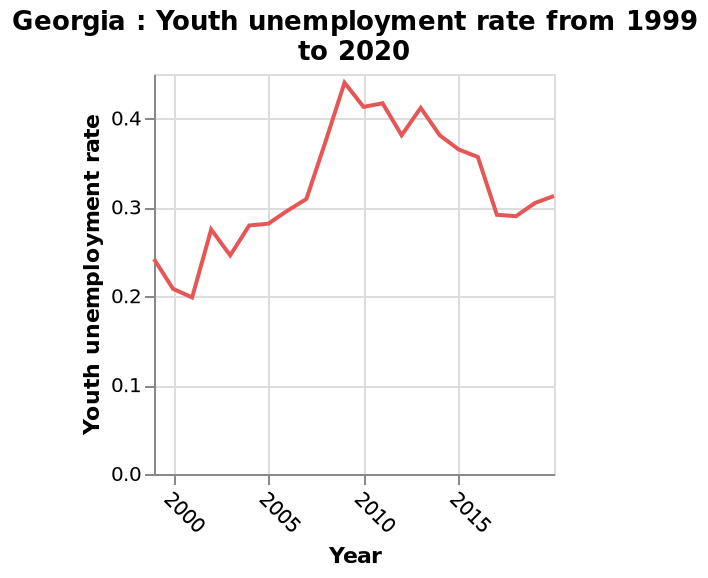<image>
Offer a thorough analysis of the image. Unemployment rate peaked in 2009 to over 0.4. The graph suggests unemployment rate among young people are improving since 2009, however the rates remain very similar. Have the unemployment rates among young people significantly changed since 2009? No, the rates remain very similar despite the improvements. Have unemployment rates among young people improved since 2009?  Yes, the graph suggests that unemployment rates among young people have been improving since 2009. Did the unemployment rate peak in 2009 to over 0.4? No.Unemployment rate peaked in 2009 to over 0.4. The graph suggests unemployment rate among young people are improving since 2009, however the rates remain very similar. 